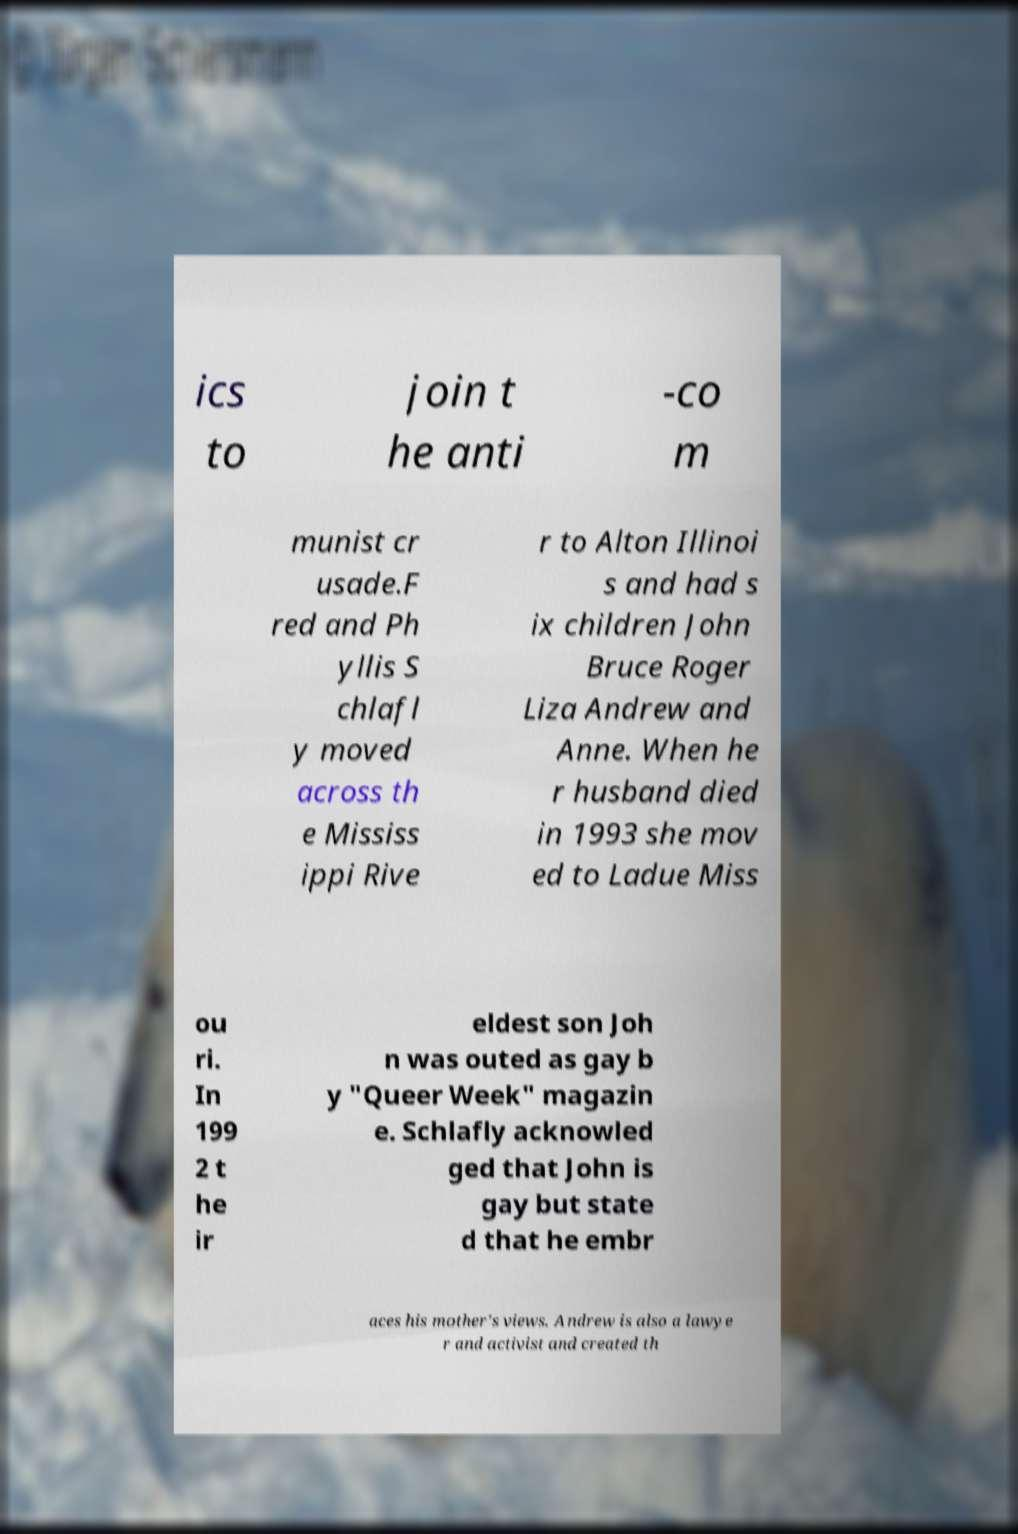There's text embedded in this image that I need extracted. Can you transcribe it verbatim? ics to join t he anti -co m munist cr usade.F red and Ph yllis S chlafl y moved across th e Mississ ippi Rive r to Alton Illinoi s and had s ix children John Bruce Roger Liza Andrew and Anne. When he r husband died in 1993 she mov ed to Ladue Miss ou ri. In 199 2 t he ir eldest son Joh n was outed as gay b y "Queer Week" magazin e. Schlafly acknowled ged that John is gay but state d that he embr aces his mother's views. Andrew is also a lawye r and activist and created th 